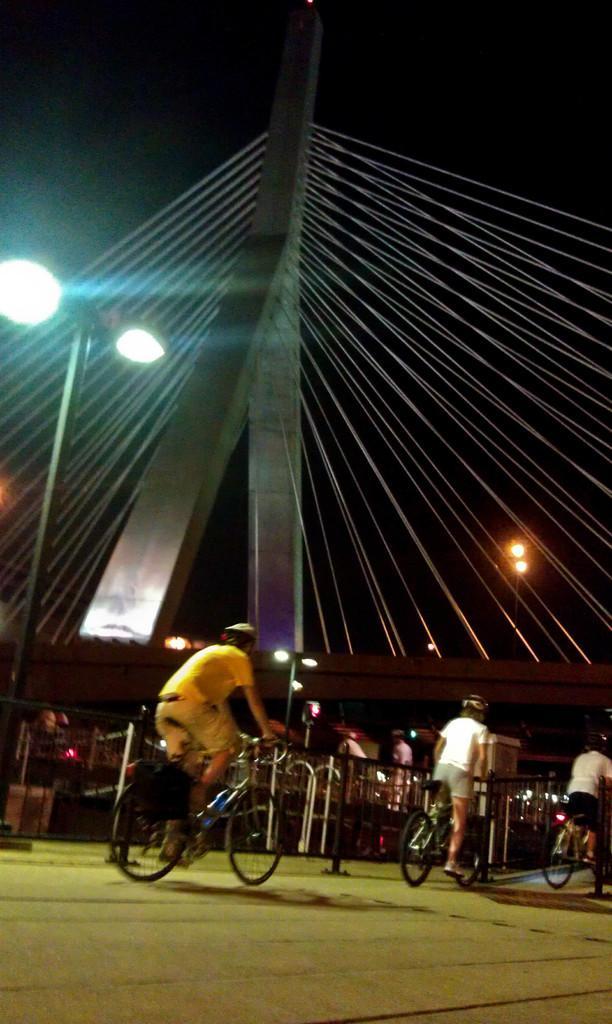Please provide a concise description of this image. At the top we can see sky and its dark. Here we can see lights. We can see few persons riding bicycles, wearing helmets. 